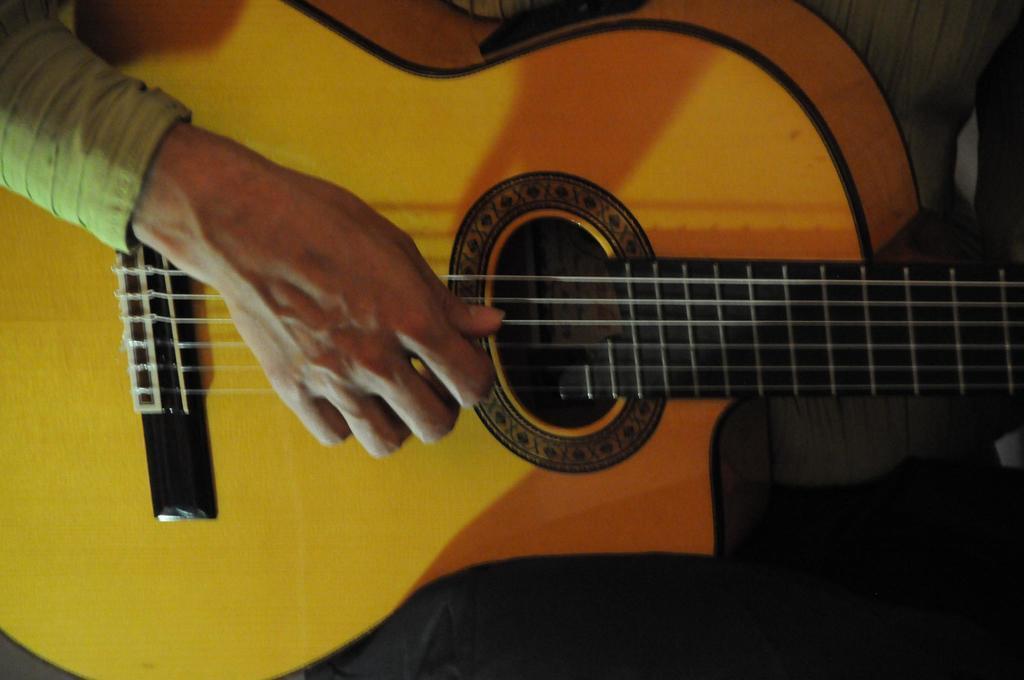Could you give a brief overview of what you see in this image? In this picture we can see a guitar with some persons hand is playing strings on it. 